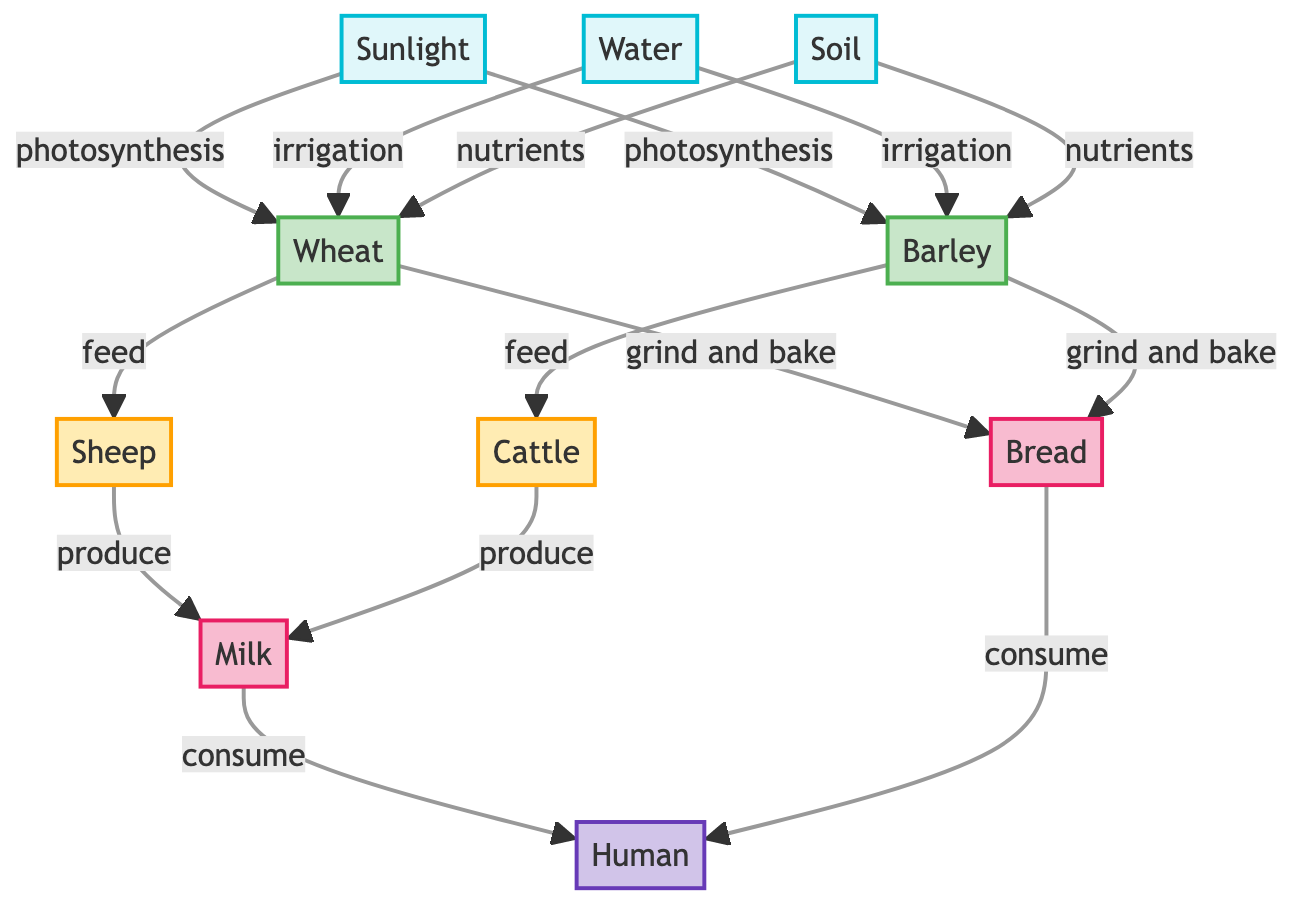What are the abiotic factors listed in the diagram? The abiotic factors mentioned in the diagram are sunlight, water, and soil. These are represented as nodes connected to crops, indicating their importance in agriculture.
Answer: Sunlight, Water, Soil How many crops are represented in this food chain? The diagram shows two crops: wheat and barley. By counting the crop nodes, we can determine that there are two crops represented.
Answer: 2 Which livestock is fed by wheat according to the diagram? In the diagram, sheep is the livestock that is specifically fed by wheat, indicated by the directional arrow leading from wheat to sheep.
Answer: Sheep What products are generated from livestock in the diagram? The products generated from livestock are milk. Both sheep and cattle produce milk, as shown by the arrows leading to the milk node.
Answer: Milk What is the relationship between barley and the consumers in the diagram? In the diagram, barley contributes to the production of bread, which is then consumed by humans. This shows a direct relationship where barley ultimately supports human consumption indirectly through products.
Answer: Humans How is milk produced according to this diagram? According to the diagram, milk is produced by both sheep and cattle. There are specific arrows leading from each livestock type to the milk product, indicating that both contribute to its production.
Answer: Sheep, Cattle How many edges lead into the product node of bread? There are two edges leading into the bread product node, one from wheat and one from barley. This indicates that both crops contribute to the bread production process.
Answer: 2 Which node receives nutrients as an input from soil? The wheat and barley nodes both receive nutrients from soil, as indicated by the arrows pointing from the soil to these crop nodes in the diagram.
Answer: Wheat, Barley What type of consumers are found in this diagram? The consumer represented in this diagram is humans, as indicated by the consumer node at the end and how it interacts with the product nodes.
Answer: Human 